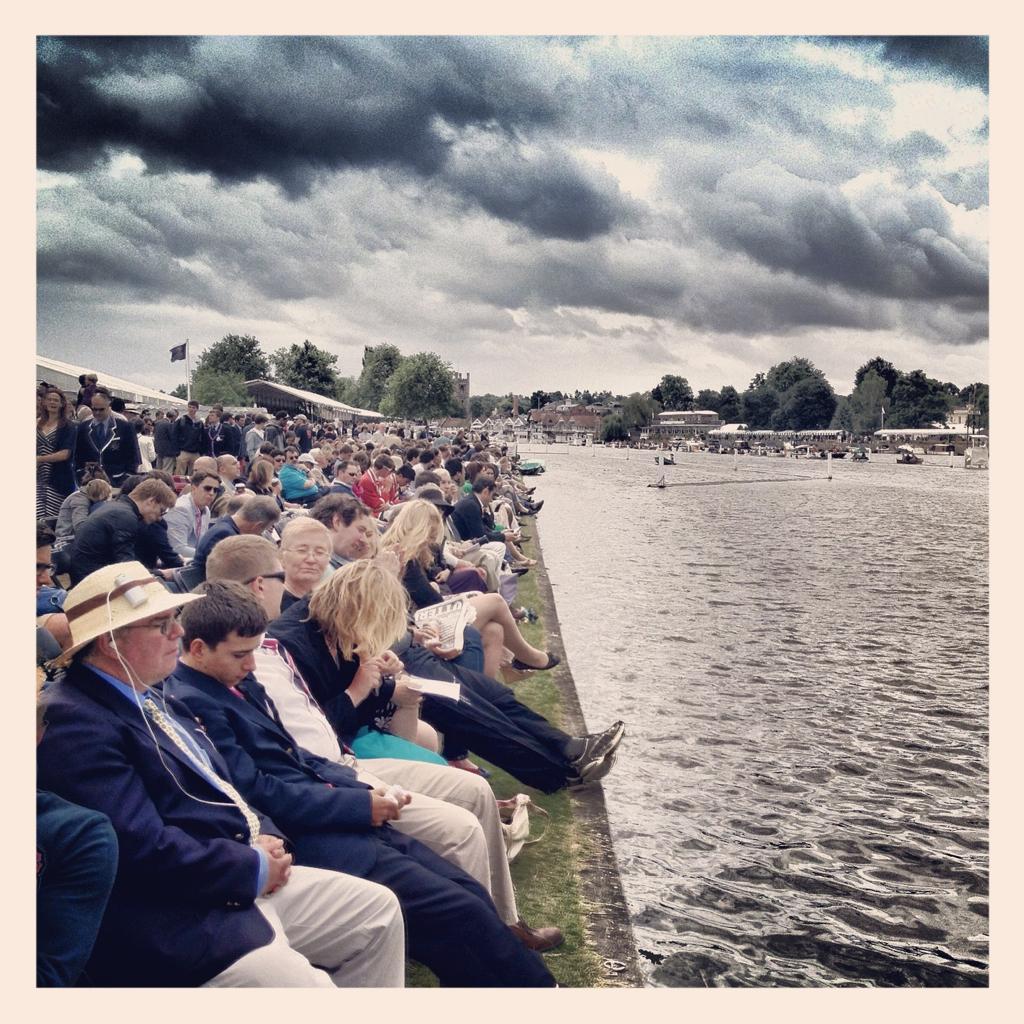Can you describe this image briefly? This picture is a photo frame. In this image, on the left side, we can see a group of people sitting. On the right side, we can see water in a lake. On the right side, we can see some trees and plants, a group people, boats which are drowning on the water, building. In the background, we can see a flag, trees, plants. At the top, we can see a sky which is cloudy, at the bottom, we can see a water and a grass on the land. 